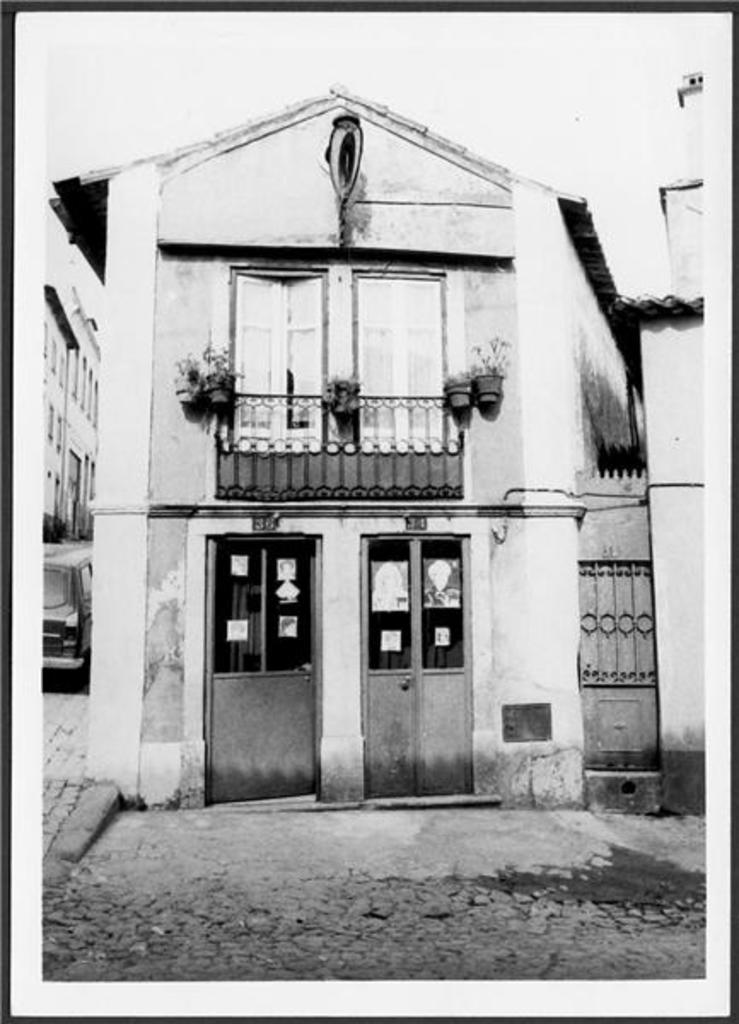What type of structure is visible in the image? There is a house in the image. What feature of the house is mentioned in the facts? The house has doors. What else can be seen attached to the fence near the house? House plants are attached to the fence. What else is present in the image besides the house? There is a vehicle and a building in the image. What type of cap is the cow wearing while sitting on the sofa in the image? There is no cap, cow, or sofa present in the image. 